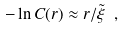Convert formula to latex. <formula><loc_0><loc_0><loc_500><loc_500>- \ln C ( r ) \approx r / \tilde { \xi } \ ,</formula> 